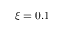<formula> <loc_0><loc_0><loc_500><loc_500>\xi = 0 . 1</formula> 